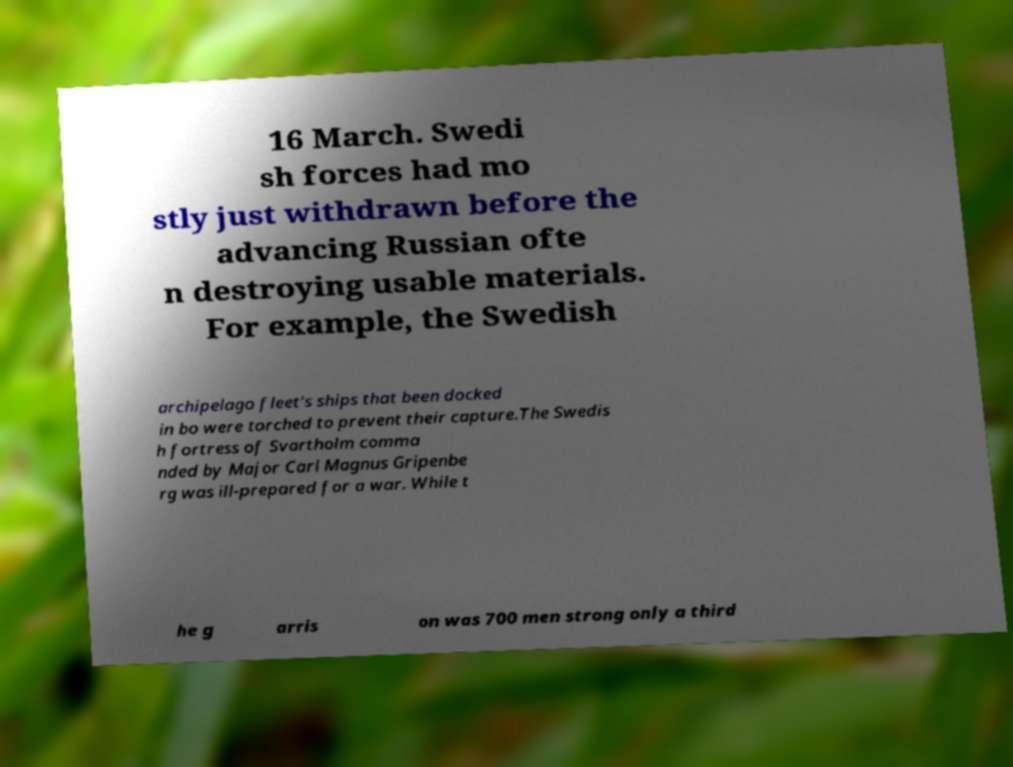What messages or text are displayed in this image? I need them in a readable, typed format. 16 March. Swedi sh forces had mo stly just withdrawn before the advancing Russian ofte n destroying usable materials. For example, the Swedish archipelago fleet's ships that been docked in bo were torched to prevent their capture.The Swedis h fortress of Svartholm comma nded by Major Carl Magnus Gripenbe rg was ill-prepared for a war. While t he g arris on was 700 men strong only a third 